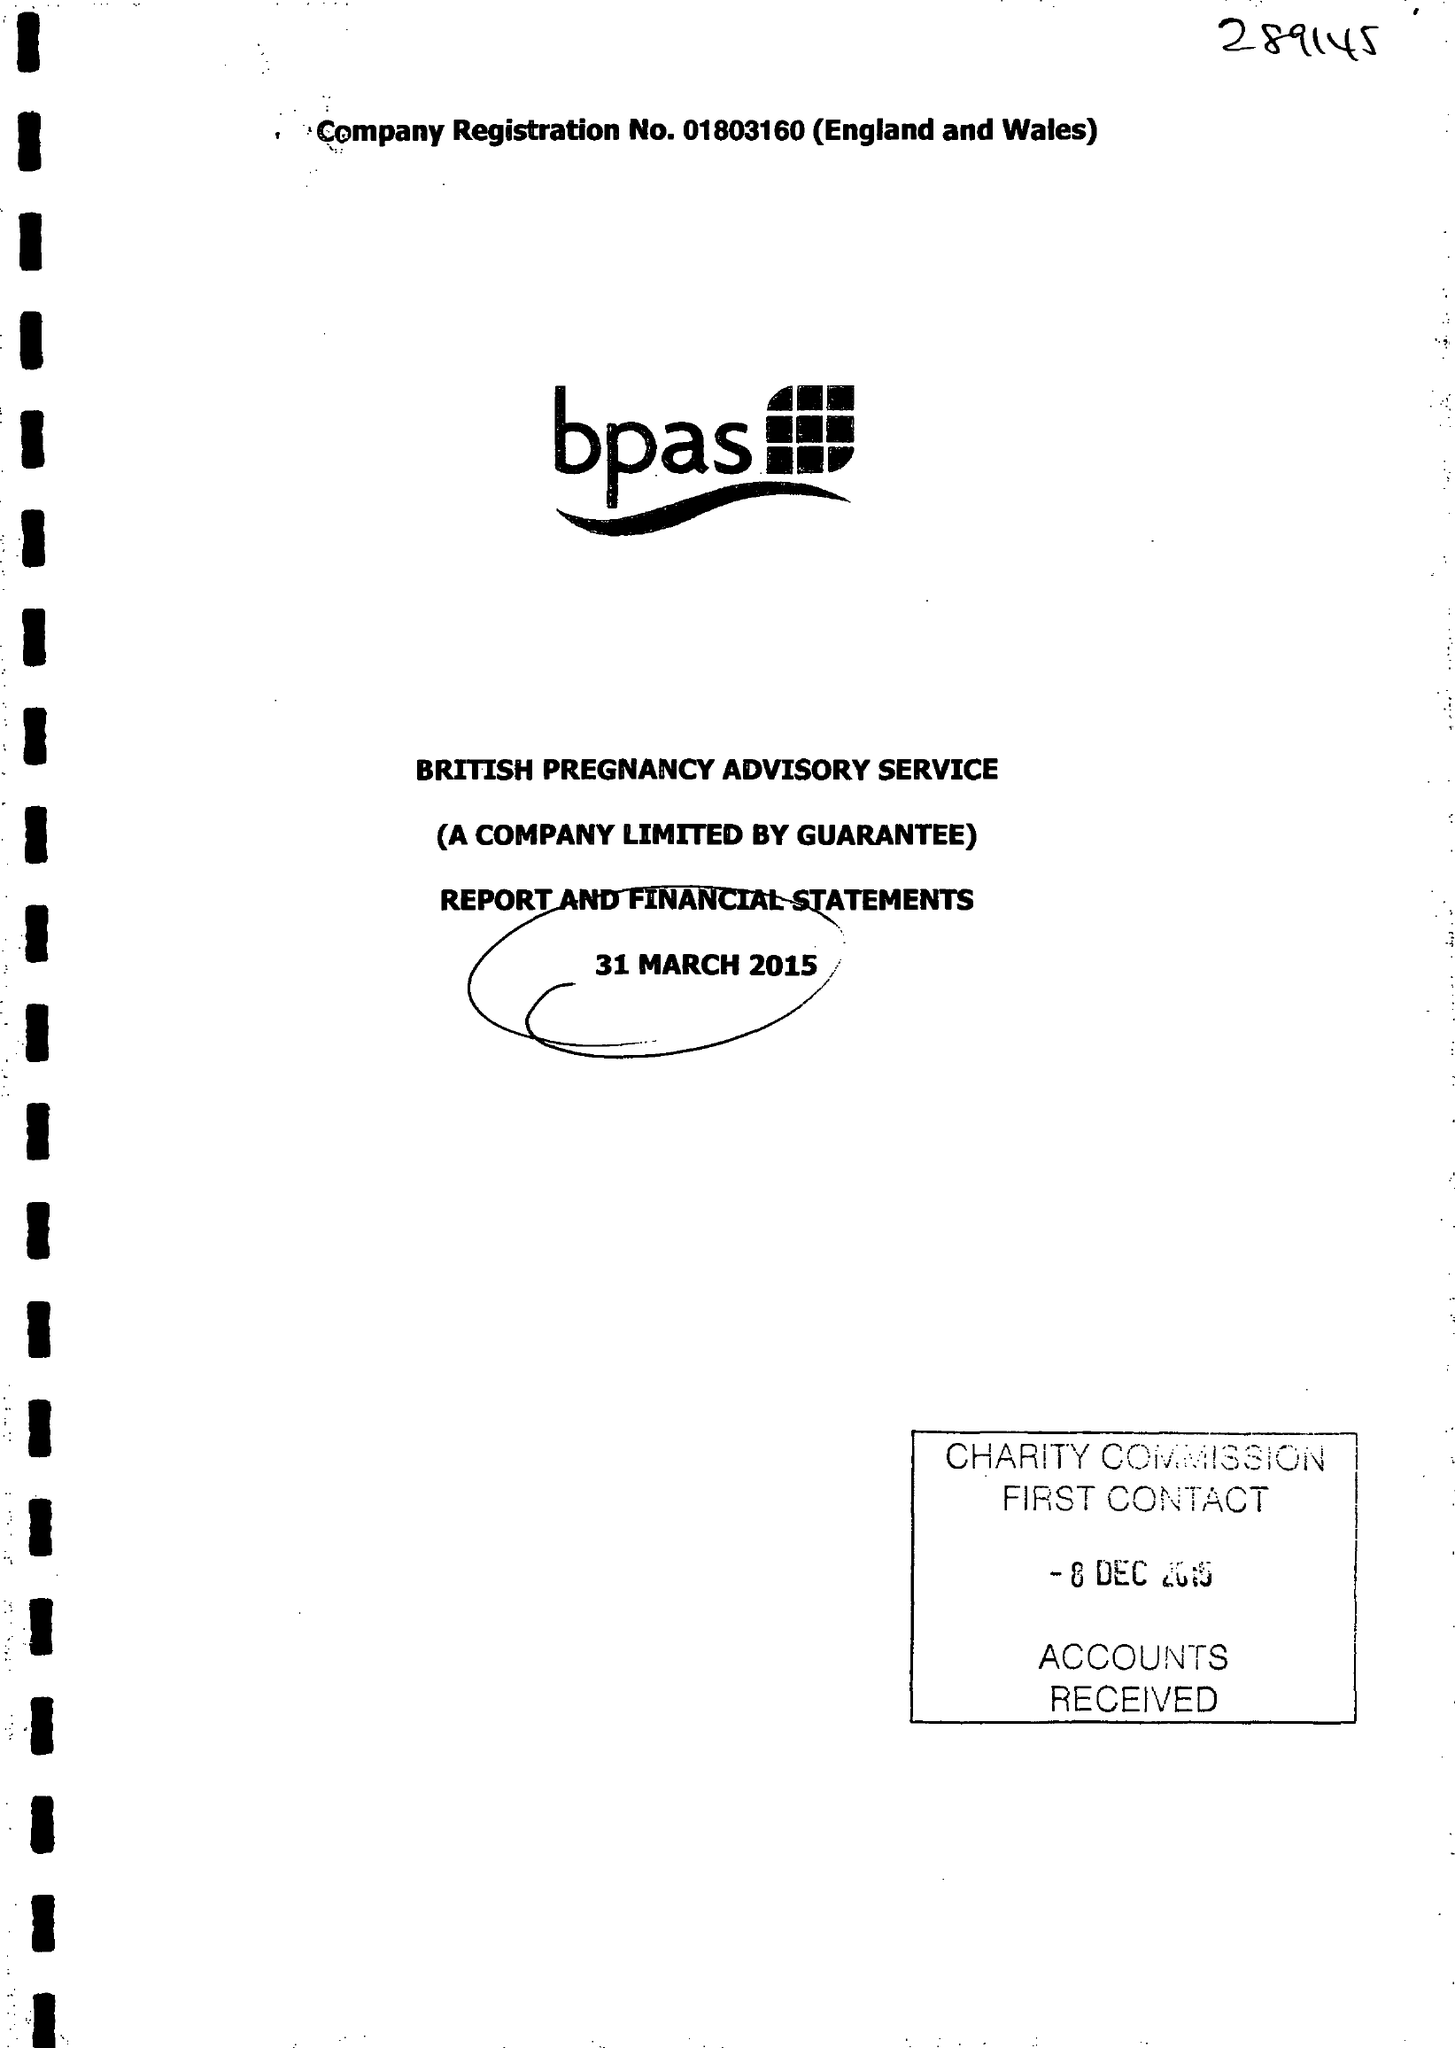What is the value for the charity_name?
Answer the question using a single word or phrase. British Pregnancy Advisory Service 